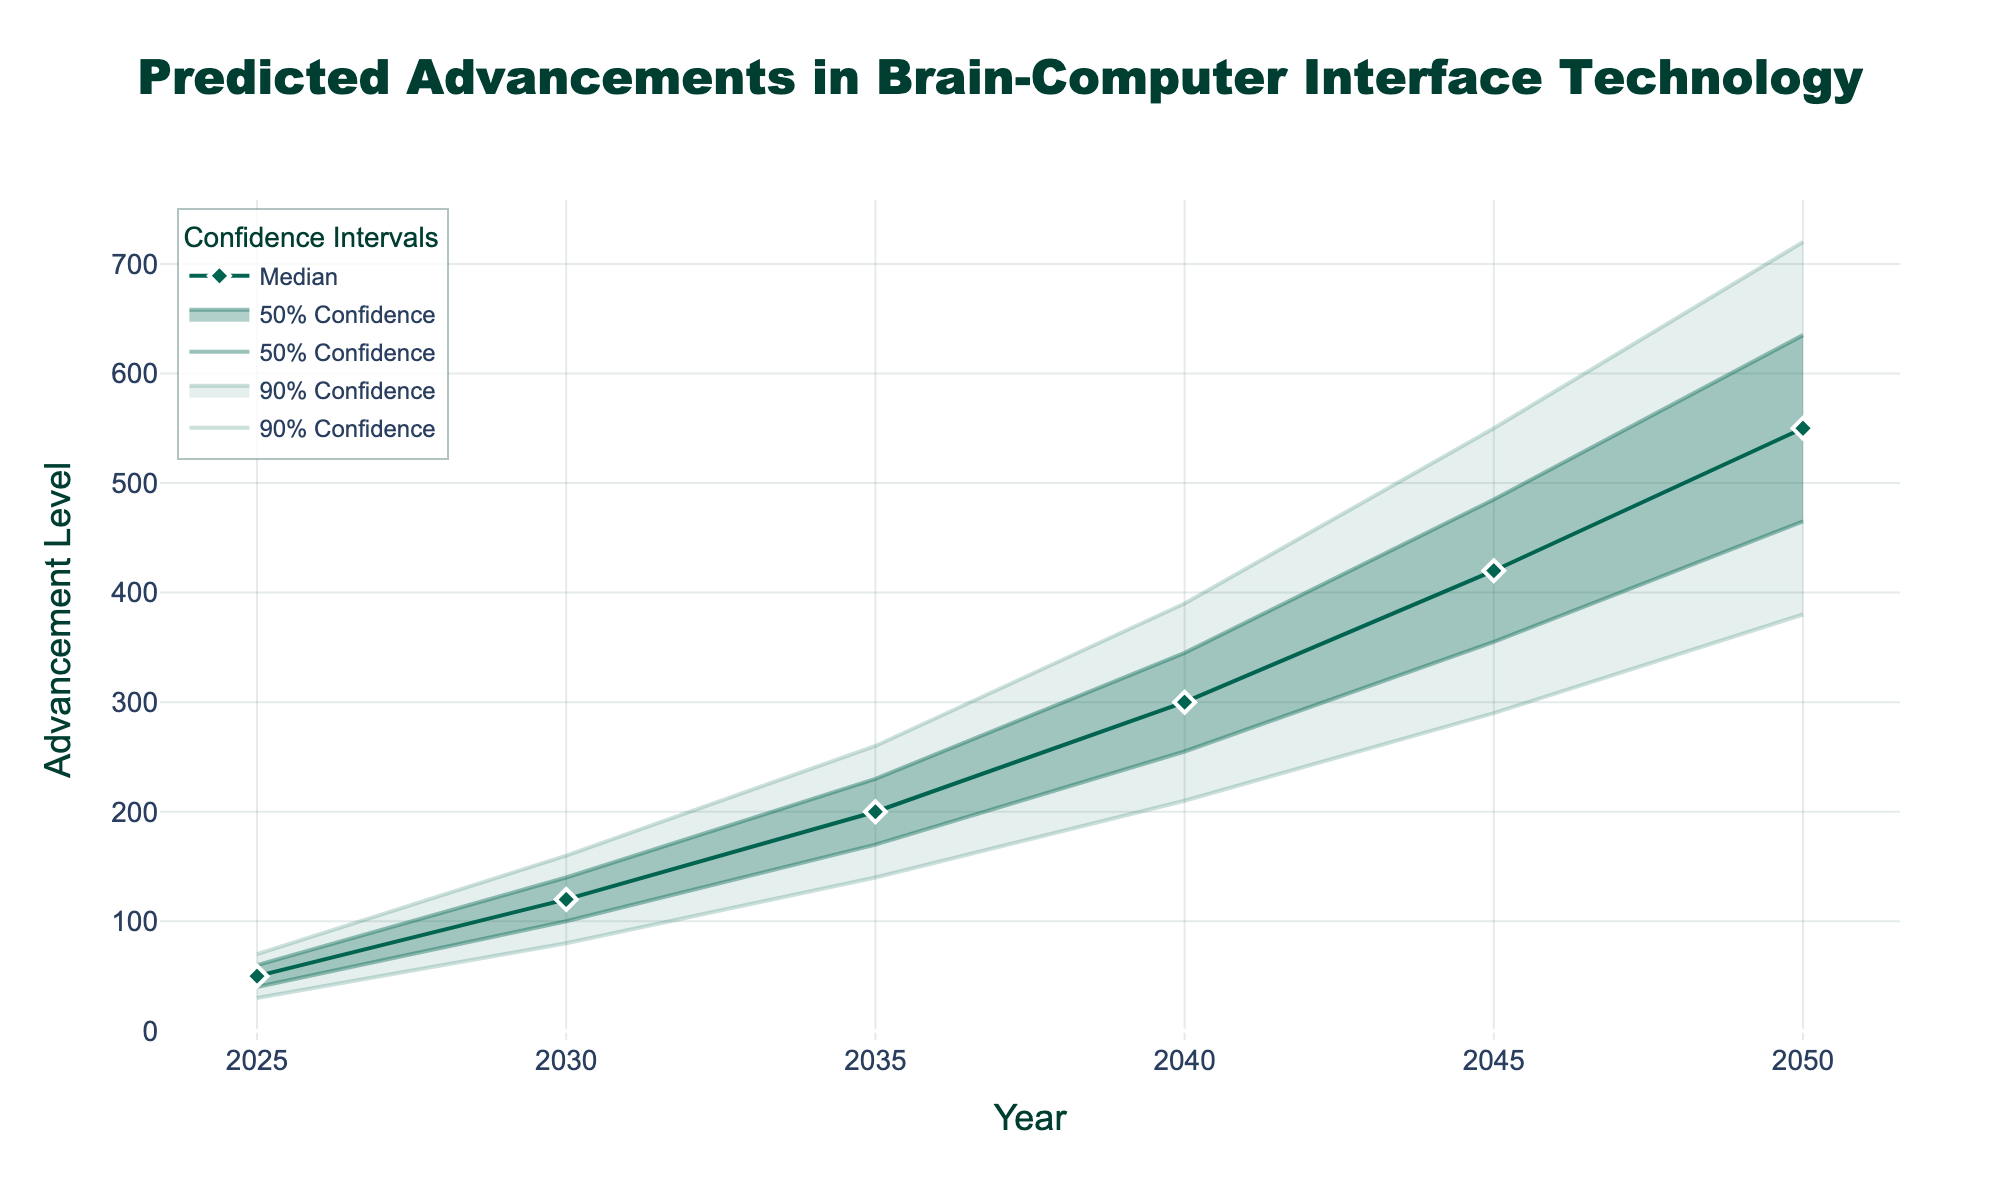What is the title of the figure? The title of the figure is the largest text positioned at the top center of the plot. From the description, it reads 'Predicted Advancements in Brain-Computer Interface Technology'.
Answer: Predicted Advancements in Brain-Computer Interface Technology What does the x-axis represent? The x-axis represents the years over which the advancements in brain-computer interface technology are being predicted. It is the horizontal axis and is labeled 'Year'.
Answer: Year What is the median advancement level predicted for the year 2030? The median advancement level for a specific year can be found by looking at the 'Median' line (solid line with markers). For the year 2030, the median value is 120.
Answer: 120 Between which years does the largest increase in the median advancement level occur? To find the largest increase, calculate the differences in median values between consecutive years and identify the largest one. The largest increase is between 2040 (300) and 2045 (420), an increase of 120.
Answer: 2040 and 2045 What is the range of advancement levels with 90% confidence in the year 2045? The 90% confidence range for a specific year is defined by the 'Lower_10' and 'Upper_10' lines. For the year 2045, the lower bound is 290 and the upper bound is 550.
Answer: 290 to 550 How do the 50% confidence intervals change from 2025 to 2050? The 50% confidence intervals are determined by the 'Lower_25' and 'Upper_75' lines. In 2025, the range is 40 to 60 (a width of 20), while in 2050, it is 465 to 635 (a width of 170). The interval widens significantly over time.
Answer: Widens significantly Which year shows the smallest uncertainty within the 90% confidence interval? The uncertainty is represented by the width of the confidence interval (Upper_10 - Lower_10). The smallest width is for the year 2025 with (70 - 30) = 40.
Answer: 2025 By how much is the advancement level expected to increase from 2035 to 2040 based on the median values? The predicted median values for 2035 and 2040 are 200 and 300 respectively. The expected increase is 300 - 200 = 100.
Answer: 100 In which year does the median prediction cross the 400 advancement level? Check the median values for each year. The median value first exceeds 400 in the year 2045 where it is 420.
Answer: 2045 What is the expected range of the 50% confidence interval in the year 2035? The 50% confidence interval is determined by the 'Lower_25' and 'Upper_75' bounds. For 2035, the range is from 170 to 230.
Answer: 170 to 230 